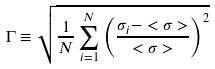Convert formula to latex. <formula><loc_0><loc_0><loc_500><loc_500>\Gamma \equiv \sqrt { \frac { 1 } { N } \sum _ { i = 1 } ^ { N } \left ( \frac { \sigma _ { i } - < \sigma > } { < \sigma > } \right ) ^ { 2 } }</formula> 